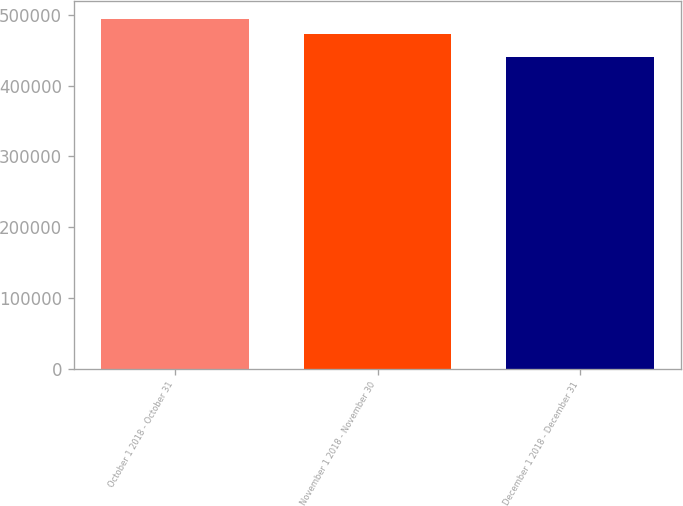Convert chart to OTSL. <chart><loc_0><loc_0><loc_500><loc_500><bar_chart><fcel>October 1 2018 - October 31<fcel>November 1 2018 - November 30<fcel>December 1 2018 - December 31<nl><fcel>494673<fcel>472233<fcel>440000<nl></chart> 